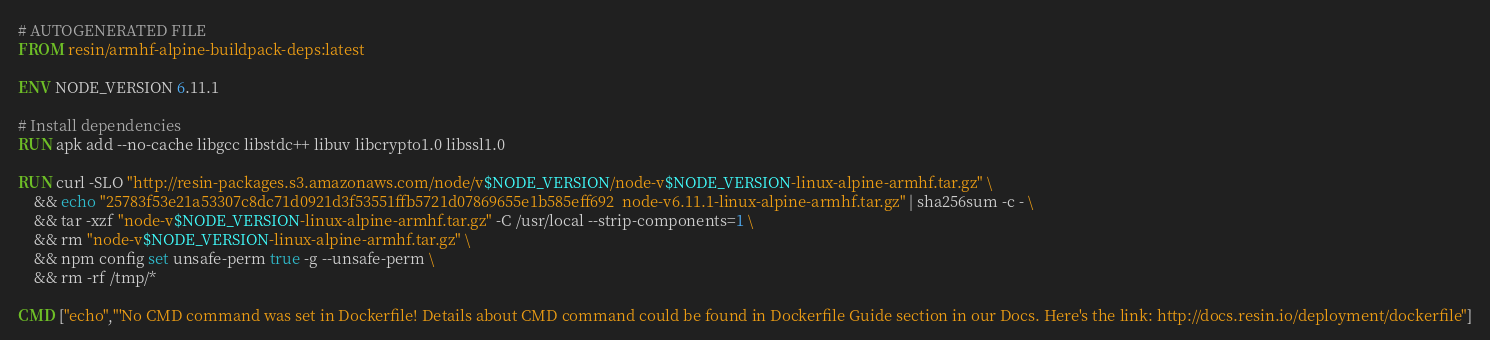<code> <loc_0><loc_0><loc_500><loc_500><_Dockerfile_># AUTOGENERATED FILE
FROM resin/armhf-alpine-buildpack-deps:latest

ENV NODE_VERSION 6.11.1

# Install dependencies
RUN apk add --no-cache libgcc libstdc++ libuv libcrypto1.0 libssl1.0

RUN curl -SLO "http://resin-packages.s3.amazonaws.com/node/v$NODE_VERSION/node-v$NODE_VERSION-linux-alpine-armhf.tar.gz" \
	&& echo "25783f53e21a53307c8dc71d0921d3f53551ffb5721d07869655e1b585eff692  node-v6.11.1-linux-alpine-armhf.tar.gz" | sha256sum -c - \
	&& tar -xzf "node-v$NODE_VERSION-linux-alpine-armhf.tar.gz" -C /usr/local --strip-components=1 \
	&& rm "node-v$NODE_VERSION-linux-alpine-armhf.tar.gz" \
	&& npm config set unsafe-perm true -g --unsafe-perm \
	&& rm -rf /tmp/*

CMD ["echo","'No CMD command was set in Dockerfile! Details about CMD command could be found in Dockerfile Guide section in our Docs. Here's the link: http://docs.resin.io/deployment/dockerfile"]
</code> 